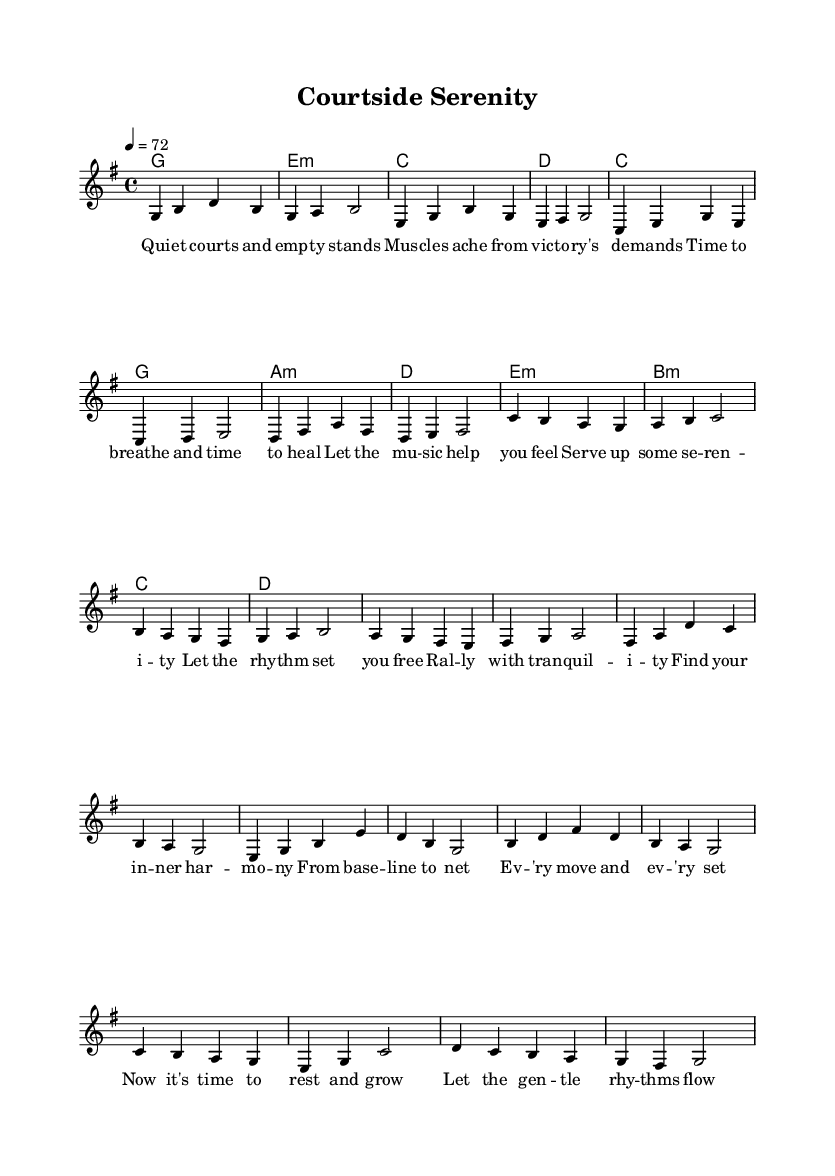What is the key signature of this music? The key signature is G major, indicated by one sharp in the signature which is represented by the 'F#' note.
Answer: G major What is the time signature of the piece? The time signature is 4/4, which is shown at the beginning of the score and indicates four beats per measure.
Answer: 4/4 What is the tempo marking for this piece? The tempo marking is "4 = 72," specifying that there are 72 quarter note beats in one minute, which is provided at the start of the global section.
Answer: 72 How many measures are in the verse section? The verse section contains 8 measures, which can be counted from the melody line indicating the end of the verse after the eighth measure.
Answer: 8 What is the first lyric of the chorus? The first lyric of the chorus is "Serve up some serenity," which is the opening line of the chorus lyrics displayed in the lyric mode.
Answer: Serve up some serenity How many distinct sections are in the song? The song has three distinct sections: Verse, Chorus, and Bridge, each indicated by their respective lyrics and musical structure in the score.
Answer: Three What is the last chord of the bridge? The last chord of the bridge is G major, noted as a single chord that follows the last measure of the bridge melody.
Answer: G 